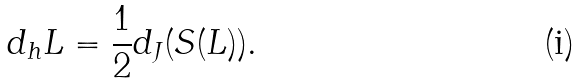Convert formula to latex. <formula><loc_0><loc_0><loc_500><loc_500>d _ { h } L = \frac { 1 } { 2 } d _ { J } ( S ( L ) ) .</formula> 